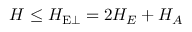Convert formula to latex. <formula><loc_0><loc_0><loc_500><loc_500>H \leq H _ { E \perp } = 2 H _ { E } + H _ { A }</formula> 